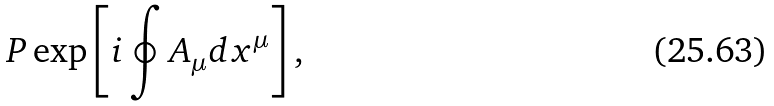Convert formula to latex. <formula><loc_0><loc_0><loc_500><loc_500>P \exp \left [ i \oint A _ { \mu } d x ^ { \mu } \right ] ,</formula> 